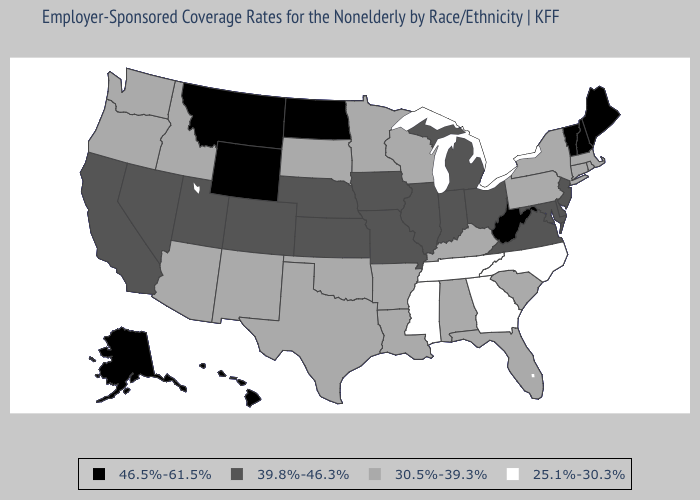Name the states that have a value in the range 39.8%-46.3%?
Concise answer only. California, Colorado, Delaware, Illinois, Indiana, Iowa, Kansas, Maryland, Michigan, Missouri, Nebraska, Nevada, New Jersey, Ohio, Utah, Virginia. Does Missouri have a lower value than Louisiana?
Answer briefly. No. Name the states that have a value in the range 46.5%-61.5%?
Concise answer only. Alaska, Hawaii, Maine, Montana, New Hampshire, North Dakota, Vermont, West Virginia, Wyoming. What is the lowest value in states that border Missouri?
Give a very brief answer. 25.1%-30.3%. What is the highest value in states that border Florida?
Give a very brief answer. 30.5%-39.3%. What is the lowest value in the West?
Be succinct. 30.5%-39.3%. Does Idaho have the highest value in the West?
Short answer required. No. What is the value of Iowa?
Keep it brief. 39.8%-46.3%. Name the states that have a value in the range 46.5%-61.5%?
Quick response, please. Alaska, Hawaii, Maine, Montana, New Hampshire, North Dakota, Vermont, West Virginia, Wyoming. What is the highest value in states that border Nebraska?
Quick response, please. 46.5%-61.5%. Does the first symbol in the legend represent the smallest category?
Concise answer only. No. What is the highest value in the USA?
Give a very brief answer. 46.5%-61.5%. What is the value of New Hampshire?
Quick response, please. 46.5%-61.5%. Does Wyoming have the lowest value in the West?
Be succinct. No. What is the value of Arizona?
Give a very brief answer. 30.5%-39.3%. 